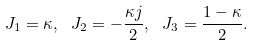<formula> <loc_0><loc_0><loc_500><loc_500>J _ { 1 } = \kappa , \ J _ { 2 } = - \frac { \kappa j } { 2 } , \ J _ { 3 } = \frac { 1 - \kappa } { 2 } .</formula> 